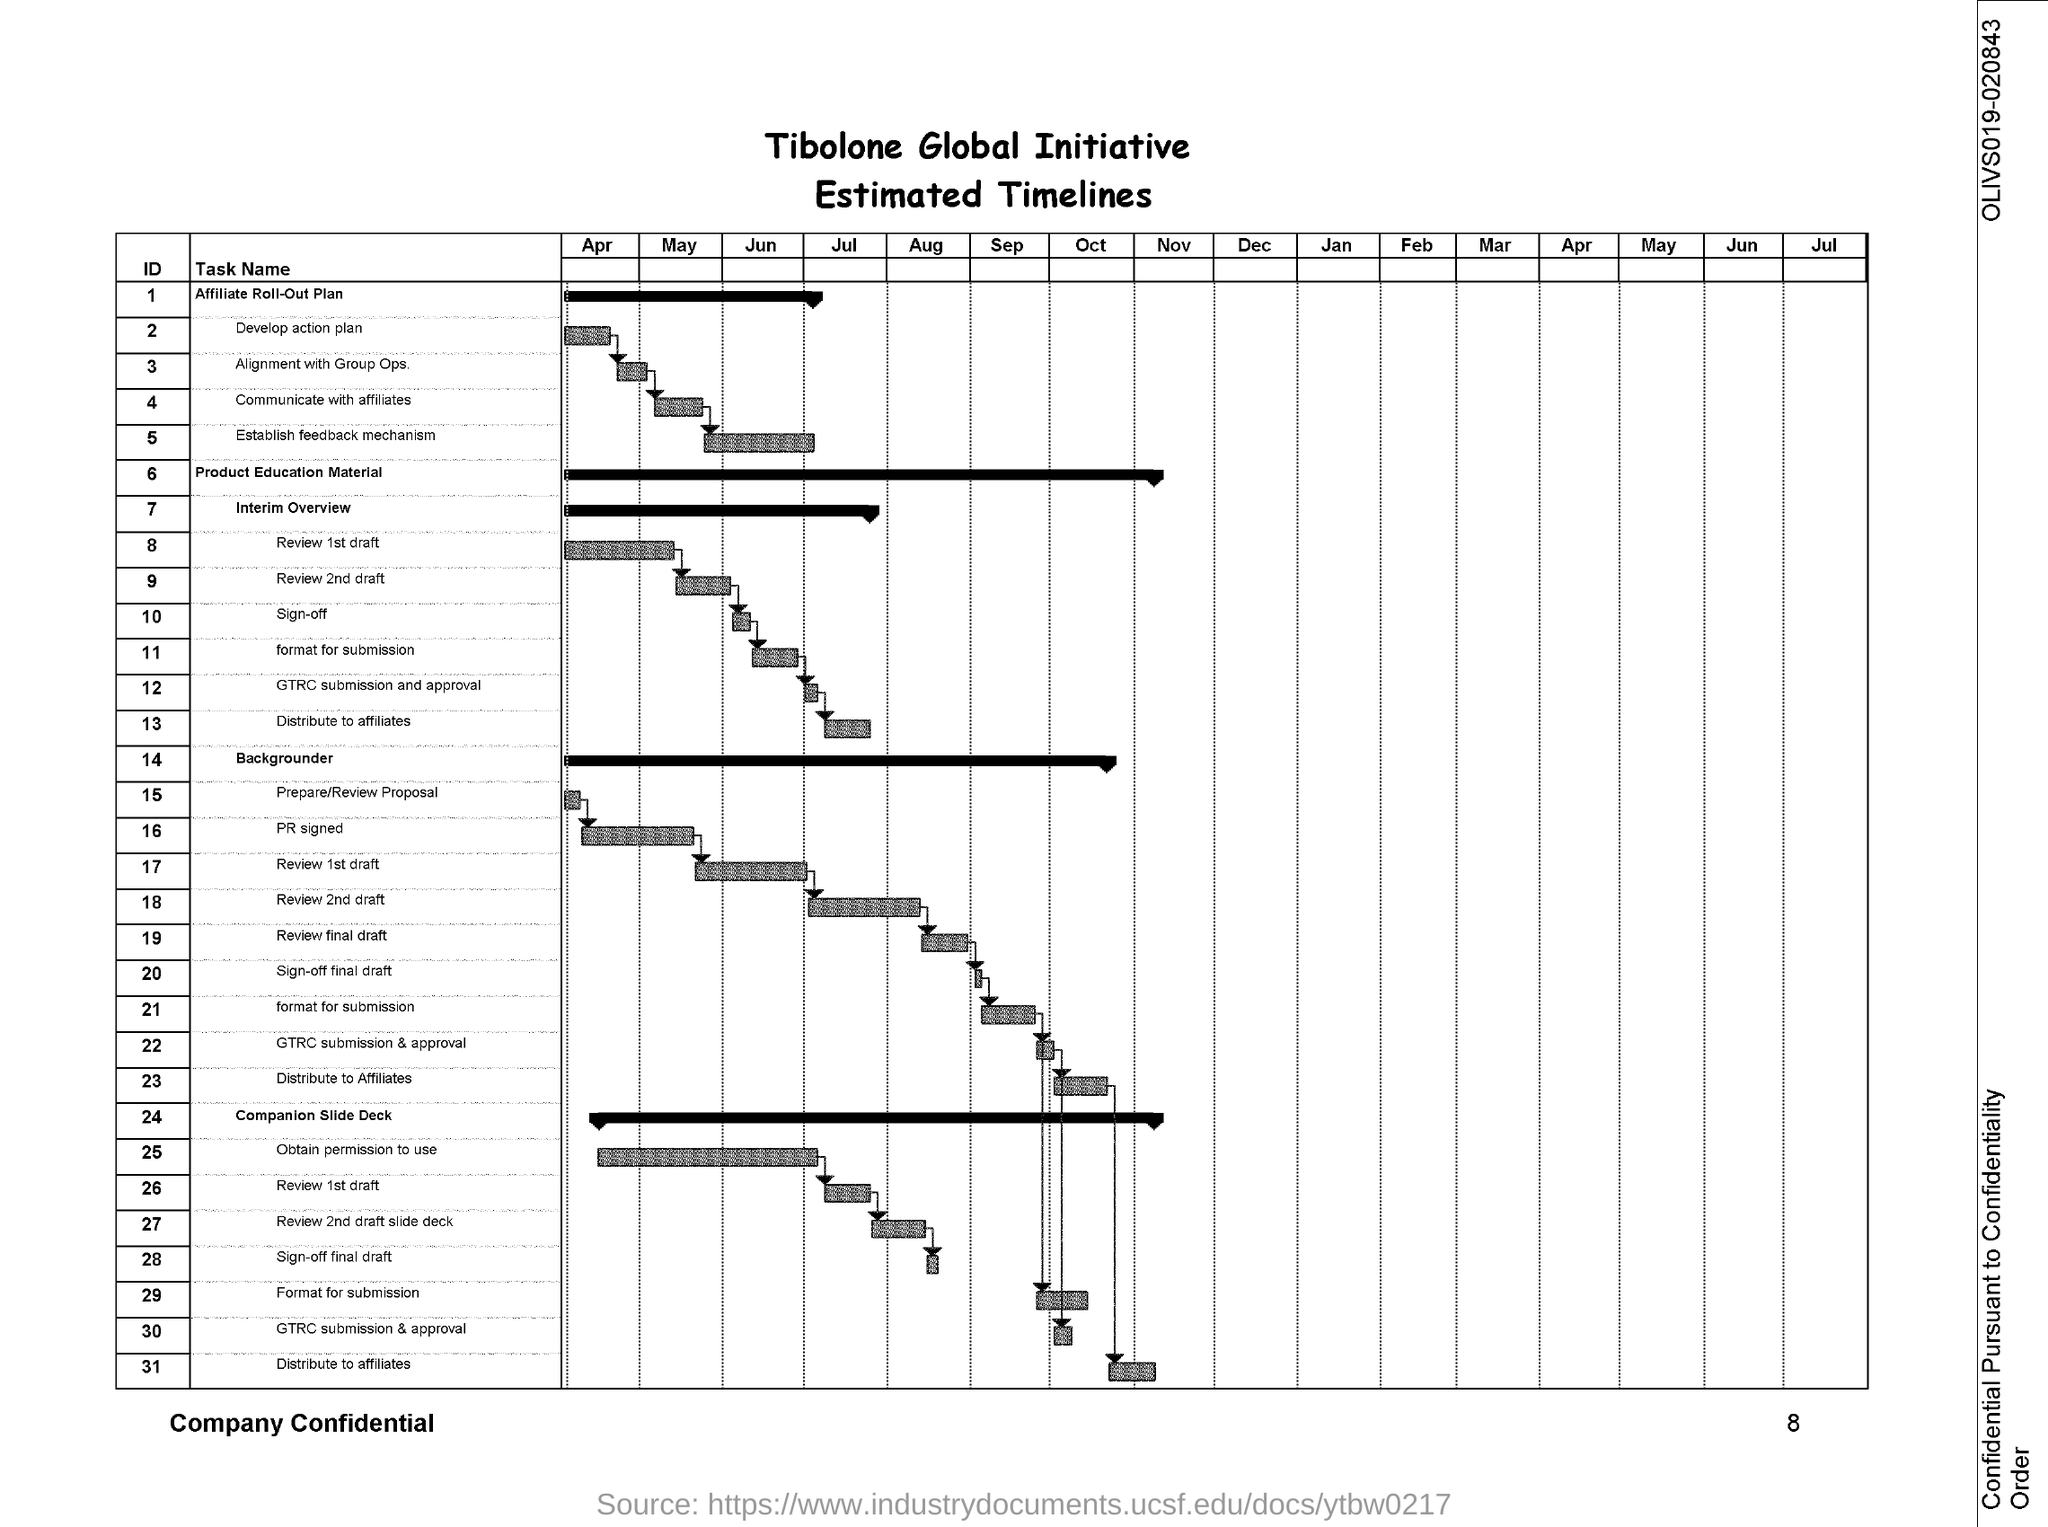Give some essential details in this illustration. The document number is "OLIVS019-020843. The page number is 8," the speaker declared confidently. 